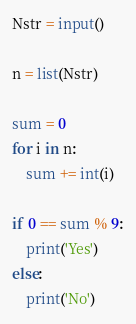<code> <loc_0><loc_0><loc_500><loc_500><_Python_>Nstr = input()

n = list(Nstr)

sum = 0
for i in n:
    sum += int(i)

if 0 == sum % 9:
    print('Yes')
else:
    print('No')
</code> 